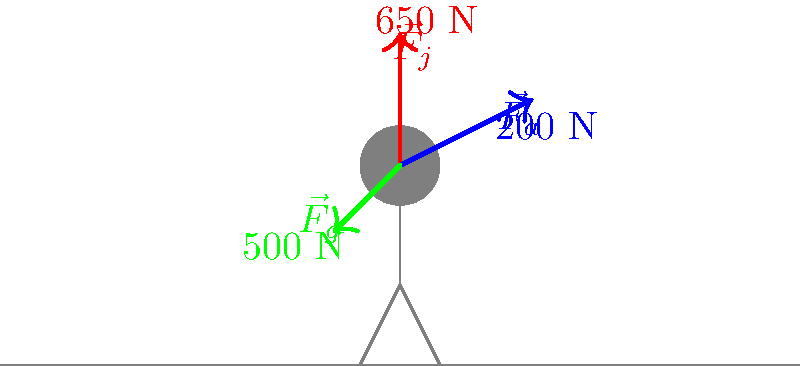During a figure skating jump, three main forces act on the skater: gravity ($\vec{F}_g$), the jump force ($\vec{F}_j$), and air resistance ($\vec{F}_a$). Given the magnitudes of these forces as shown in the diagram, calculate the magnitude of the net force acting on the skater during the initial moment of the jump. To find the net force, we need to add the force vectors using the following steps:

1) First, let's establish a coordinate system. We'll use the positive y-axis pointing upward and the positive x-axis pointing to the right.

2) Now, let's break down each force into its x and y components:

   $\vec{F}_g$: 500 N downward
   x-component: 0 N
   y-component: -500 N

   $\vec{F}_j$: 650 N upward
   x-component: 0 N
   y-component: 650 N

   $\vec{F}_a$: 200 N, angled upward and to the right
   Assuming a 45° angle (based on the diagram):
   x-component: 200 * cos(45°) ≈ 141.4 N
   y-component: 200 * sin(45°) ≈ 141.4 N

3) Sum the components:
   Net force in x-direction: 141.4 N
   Net force in y-direction: 650 + 141.4 - 500 = 291.4 N

4) Calculate the magnitude of the net force using the Pythagorean theorem:

   $|\vec{F}_{net}| = \sqrt{(141.4)^2 + (291.4)^2} \approx 323.7$ N

Therefore, the magnitude of the net force acting on the skater is approximately 323.7 N.
Answer: 323.7 N 